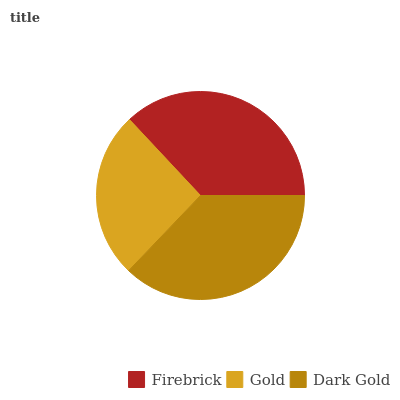Is Gold the minimum?
Answer yes or no. Yes. Is Dark Gold the maximum?
Answer yes or no. Yes. Is Dark Gold the minimum?
Answer yes or no. No. Is Gold the maximum?
Answer yes or no. No. Is Dark Gold greater than Gold?
Answer yes or no. Yes. Is Gold less than Dark Gold?
Answer yes or no. Yes. Is Gold greater than Dark Gold?
Answer yes or no. No. Is Dark Gold less than Gold?
Answer yes or no. No. Is Firebrick the high median?
Answer yes or no. Yes. Is Firebrick the low median?
Answer yes or no. Yes. Is Dark Gold the high median?
Answer yes or no. No. Is Dark Gold the low median?
Answer yes or no. No. 